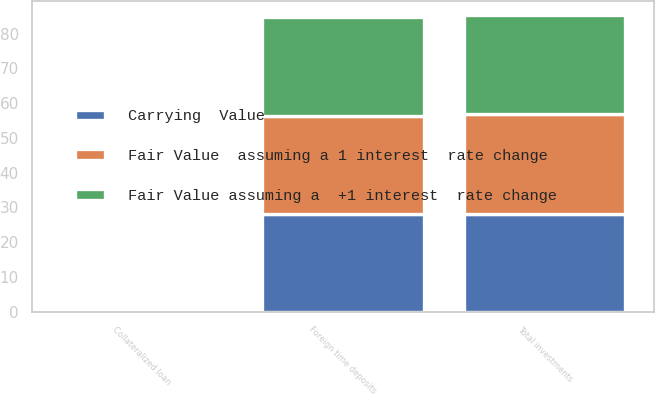Convert chart. <chart><loc_0><loc_0><loc_500><loc_500><stacked_bar_chart><ecel><fcel>Collateralized loan<fcel>Foreign time deposits<fcel>Total investments<nl><fcel>Fair Value  assuming a 1 interest  rate change<fcel>0.5<fcel>28.2<fcel>28.7<nl><fcel>Fair Value assuming a  +1 interest  rate change<fcel>0.5<fcel>28.3<fcel>28.3<nl><fcel>Carrying  Value<fcel>0.5<fcel>28.2<fcel>28.2<nl></chart> 